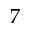<formula> <loc_0><loc_0><loc_500><loc_500>7</formula> 